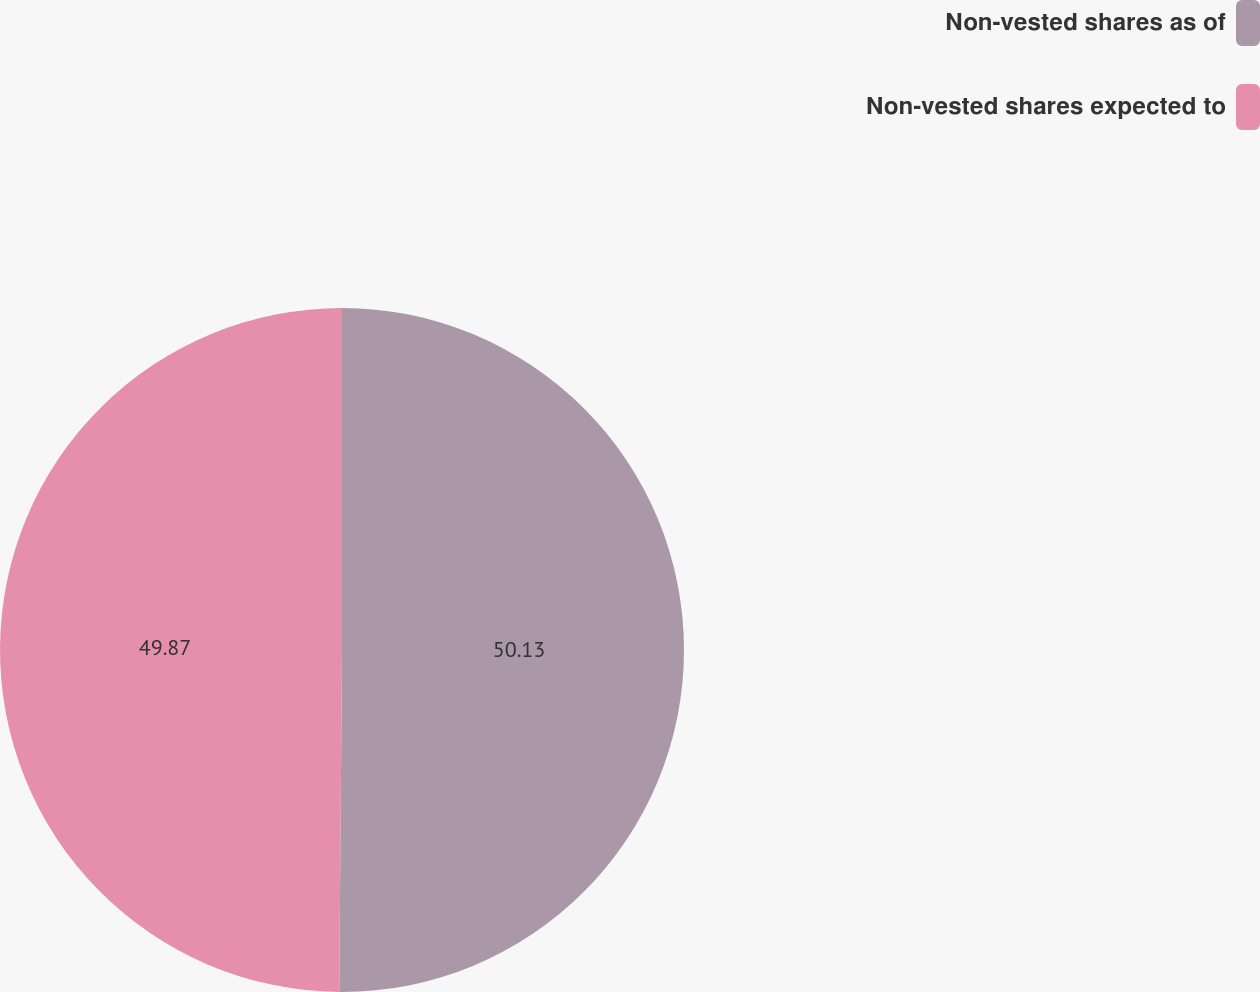Convert chart. <chart><loc_0><loc_0><loc_500><loc_500><pie_chart><fcel>Non-vested shares as of<fcel>Non-vested shares expected to<nl><fcel>50.13%<fcel>49.87%<nl></chart> 